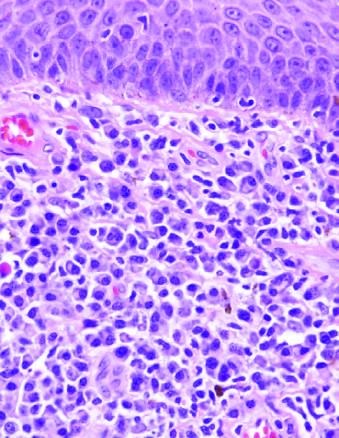do histologic features of the chancre include a diffuse plasma cell infiltrate beneath squamous epithelium of skin?
Answer the question using a single word or phrase. Yes 